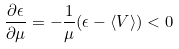<formula> <loc_0><loc_0><loc_500><loc_500>\frac { \partial \epsilon } { \partial \mu } = - \frac { 1 } { \mu } ( \epsilon - \langle V \rangle ) < 0</formula> 